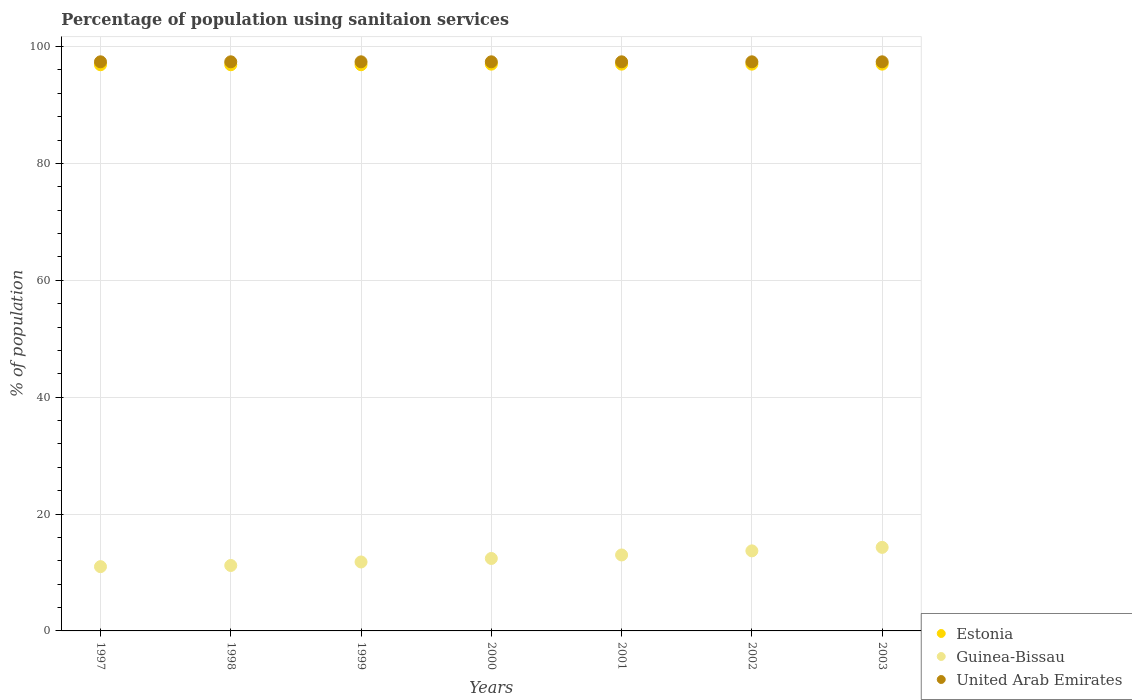How many different coloured dotlines are there?
Provide a short and direct response. 3. What is the percentage of population using sanitaion services in Estonia in 1999?
Offer a very short reply. 96.9. Across all years, what is the maximum percentage of population using sanitaion services in Estonia?
Your response must be concise. 97. Across all years, what is the minimum percentage of population using sanitaion services in Estonia?
Offer a very short reply. 96.9. In which year was the percentage of population using sanitaion services in Estonia maximum?
Provide a succinct answer. 2000. What is the total percentage of population using sanitaion services in Guinea-Bissau in the graph?
Your response must be concise. 87.4. What is the difference between the percentage of population using sanitaion services in Guinea-Bissau in 1999 and that in 2001?
Give a very brief answer. -1.2. What is the difference between the percentage of population using sanitaion services in United Arab Emirates in 1999 and the percentage of population using sanitaion services in Estonia in 2000?
Your response must be concise. 0.4. What is the average percentage of population using sanitaion services in Estonia per year?
Your answer should be compact. 96.96. In the year 2000, what is the difference between the percentage of population using sanitaion services in Estonia and percentage of population using sanitaion services in United Arab Emirates?
Offer a terse response. -0.4. In how many years, is the percentage of population using sanitaion services in Estonia greater than 56 %?
Your answer should be compact. 7. What is the ratio of the percentage of population using sanitaion services in Guinea-Bissau in 2000 to that in 2001?
Your answer should be very brief. 0.95. What is the difference between the highest and the second highest percentage of population using sanitaion services in Estonia?
Make the answer very short. 0. What is the difference between the highest and the lowest percentage of population using sanitaion services in Guinea-Bissau?
Provide a short and direct response. 3.3. Is it the case that in every year, the sum of the percentage of population using sanitaion services in United Arab Emirates and percentage of population using sanitaion services in Guinea-Bissau  is greater than the percentage of population using sanitaion services in Estonia?
Ensure brevity in your answer.  Yes. Is the percentage of population using sanitaion services in United Arab Emirates strictly less than the percentage of population using sanitaion services in Estonia over the years?
Your answer should be very brief. No. How many dotlines are there?
Give a very brief answer. 3. How many years are there in the graph?
Provide a succinct answer. 7. Does the graph contain any zero values?
Provide a succinct answer. No. Where does the legend appear in the graph?
Provide a succinct answer. Bottom right. How are the legend labels stacked?
Your answer should be very brief. Vertical. What is the title of the graph?
Keep it short and to the point. Percentage of population using sanitaion services. What is the label or title of the Y-axis?
Provide a short and direct response. % of population. What is the % of population of Estonia in 1997?
Ensure brevity in your answer.  96.9. What is the % of population in Guinea-Bissau in 1997?
Offer a terse response. 11. What is the % of population in United Arab Emirates in 1997?
Provide a short and direct response. 97.4. What is the % of population of Estonia in 1998?
Your response must be concise. 96.9. What is the % of population in Guinea-Bissau in 1998?
Ensure brevity in your answer.  11.2. What is the % of population in United Arab Emirates in 1998?
Give a very brief answer. 97.4. What is the % of population of Estonia in 1999?
Your answer should be very brief. 96.9. What is the % of population in Guinea-Bissau in 1999?
Offer a terse response. 11.8. What is the % of population of United Arab Emirates in 1999?
Ensure brevity in your answer.  97.4. What is the % of population in Estonia in 2000?
Offer a terse response. 97. What is the % of population in Guinea-Bissau in 2000?
Provide a short and direct response. 12.4. What is the % of population of United Arab Emirates in 2000?
Keep it short and to the point. 97.4. What is the % of population in Estonia in 2001?
Offer a terse response. 97. What is the % of population of United Arab Emirates in 2001?
Keep it short and to the point. 97.4. What is the % of population in Estonia in 2002?
Your answer should be very brief. 97. What is the % of population in Guinea-Bissau in 2002?
Your answer should be compact. 13.7. What is the % of population of United Arab Emirates in 2002?
Provide a short and direct response. 97.4. What is the % of population in Estonia in 2003?
Provide a short and direct response. 97. What is the % of population in United Arab Emirates in 2003?
Offer a very short reply. 97.4. Across all years, what is the maximum % of population of Estonia?
Make the answer very short. 97. Across all years, what is the maximum % of population in Guinea-Bissau?
Give a very brief answer. 14.3. Across all years, what is the maximum % of population of United Arab Emirates?
Ensure brevity in your answer.  97.4. Across all years, what is the minimum % of population of Estonia?
Make the answer very short. 96.9. Across all years, what is the minimum % of population in Guinea-Bissau?
Your response must be concise. 11. Across all years, what is the minimum % of population of United Arab Emirates?
Your answer should be compact. 97.4. What is the total % of population in Estonia in the graph?
Your answer should be very brief. 678.7. What is the total % of population in Guinea-Bissau in the graph?
Your answer should be compact. 87.4. What is the total % of population in United Arab Emirates in the graph?
Your answer should be compact. 681.8. What is the difference between the % of population of Estonia in 1997 and that in 1998?
Provide a short and direct response. 0. What is the difference between the % of population in Guinea-Bissau in 1997 and that in 1998?
Your answer should be compact. -0.2. What is the difference between the % of population in United Arab Emirates in 1997 and that in 1998?
Offer a terse response. 0. What is the difference between the % of population of Estonia in 1997 and that in 1999?
Provide a short and direct response. 0. What is the difference between the % of population of Guinea-Bissau in 1997 and that in 1999?
Provide a succinct answer. -0.8. What is the difference between the % of population of United Arab Emirates in 1997 and that in 1999?
Ensure brevity in your answer.  0. What is the difference between the % of population of Guinea-Bissau in 1997 and that in 2000?
Your answer should be compact. -1.4. What is the difference between the % of population of United Arab Emirates in 1997 and that in 2000?
Offer a very short reply. 0. What is the difference between the % of population in Guinea-Bissau in 1997 and that in 2001?
Your answer should be compact. -2. What is the difference between the % of population of United Arab Emirates in 1997 and that in 2001?
Keep it short and to the point. 0. What is the difference between the % of population of Estonia in 1997 and that in 2003?
Offer a very short reply. -0.1. What is the difference between the % of population in Guinea-Bissau in 1997 and that in 2003?
Offer a terse response. -3.3. What is the difference between the % of population in Estonia in 1998 and that in 1999?
Offer a terse response. 0. What is the difference between the % of population in Guinea-Bissau in 1998 and that in 1999?
Your answer should be compact. -0.6. What is the difference between the % of population of United Arab Emirates in 1998 and that in 2000?
Your answer should be compact. 0. What is the difference between the % of population of Estonia in 1998 and that in 2001?
Make the answer very short. -0.1. What is the difference between the % of population in Guinea-Bissau in 1998 and that in 2001?
Offer a very short reply. -1.8. What is the difference between the % of population of Estonia in 1998 and that in 2002?
Provide a succinct answer. -0.1. What is the difference between the % of population in Estonia in 1999 and that in 2000?
Offer a terse response. -0.1. What is the difference between the % of population of Guinea-Bissau in 1999 and that in 2000?
Ensure brevity in your answer.  -0.6. What is the difference between the % of population in United Arab Emirates in 1999 and that in 2000?
Your response must be concise. 0. What is the difference between the % of population of Guinea-Bissau in 1999 and that in 2001?
Your response must be concise. -1.2. What is the difference between the % of population of United Arab Emirates in 1999 and that in 2001?
Provide a succinct answer. 0. What is the difference between the % of population in Estonia in 1999 and that in 2002?
Offer a very short reply. -0.1. What is the difference between the % of population of Guinea-Bissau in 1999 and that in 2002?
Offer a very short reply. -1.9. What is the difference between the % of population in United Arab Emirates in 1999 and that in 2002?
Ensure brevity in your answer.  0. What is the difference between the % of population in Guinea-Bissau in 1999 and that in 2003?
Provide a short and direct response. -2.5. What is the difference between the % of population in United Arab Emirates in 1999 and that in 2003?
Offer a terse response. 0. What is the difference between the % of population of Estonia in 2000 and that in 2001?
Offer a terse response. 0. What is the difference between the % of population of Estonia in 2000 and that in 2002?
Offer a very short reply. 0. What is the difference between the % of population of Guinea-Bissau in 2000 and that in 2002?
Your response must be concise. -1.3. What is the difference between the % of population in United Arab Emirates in 2000 and that in 2002?
Keep it short and to the point. 0. What is the difference between the % of population in Estonia in 2000 and that in 2003?
Provide a short and direct response. 0. What is the difference between the % of population in Guinea-Bissau in 2000 and that in 2003?
Your answer should be very brief. -1.9. What is the difference between the % of population of Estonia in 2001 and that in 2002?
Your response must be concise. 0. What is the difference between the % of population in Estonia in 2001 and that in 2003?
Give a very brief answer. 0. What is the difference between the % of population of Guinea-Bissau in 2001 and that in 2003?
Your answer should be compact. -1.3. What is the difference between the % of population of Estonia in 2002 and that in 2003?
Your answer should be compact. 0. What is the difference between the % of population of Estonia in 1997 and the % of population of Guinea-Bissau in 1998?
Give a very brief answer. 85.7. What is the difference between the % of population in Estonia in 1997 and the % of population in United Arab Emirates in 1998?
Ensure brevity in your answer.  -0.5. What is the difference between the % of population of Guinea-Bissau in 1997 and the % of population of United Arab Emirates in 1998?
Your answer should be very brief. -86.4. What is the difference between the % of population of Estonia in 1997 and the % of population of Guinea-Bissau in 1999?
Your answer should be very brief. 85.1. What is the difference between the % of population of Guinea-Bissau in 1997 and the % of population of United Arab Emirates in 1999?
Keep it short and to the point. -86.4. What is the difference between the % of population in Estonia in 1997 and the % of population in Guinea-Bissau in 2000?
Make the answer very short. 84.5. What is the difference between the % of population of Guinea-Bissau in 1997 and the % of population of United Arab Emirates in 2000?
Offer a terse response. -86.4. What is the difference between the % of population in Estonia in 1997 and the % of population in Guinea-Bissau in 2001?
Your answer should be compact. 83.9. What is the difference between the % of population in Guinea-Bissau in 1997 and the % of population in United Arab Emirates in 2001?
Offer a very short reply. -86.4. What is the difference between the % of population of Estonia in 1997 and the % of population of Guinea-Bissau in 2002?
Your answer should be compact. 83.2. What is the difference between the % of population in Guinea-Bissau in 1997 and the % of population in United Arab Emirates in 2002?
Provide a short and direct response. -86.4. What is the difference between the % of population in Estonia in 1997 and the % of population in Guinea-Bissau in 2003?
Offer a terse response. 82.6. What is the difference between the % of population of Guinea-Bissau in 1997 and the % of population of United Arab Emirates in 2003?
Your answer should be very brief. -86.4. What is the difference between the % of population of Estonia in 1998 and the % of population of Guinea-Bissau in 1999?
Offer a very short reply. 85.1. What is the difference between the % of population of Guinea-Bissau in 1998 and the % of population of United Arab Emirates in 1999?
Offer a terse response. -86.2. What is the difference between the % of population of Estonia in 1998 and the % of population of Guinea-Bissau in 2000?
Provide a succinct answer. 84.5. What is the difference between the % of population in Estonia in 1998 and the % of population in United Arab Emirates in 2000?
Provide a succinct answer. -0.5. What is the difference between the % of population of Guinea-Bissau in 1998 and the % of population of United Arab Emirates in 2000?
Ensure brevity in your answer.  -86.2. What is the difference between the % of population of Estonia in 1998 and the % of population of Guinea-Bissau in 2001?
Your response must be concise. 83.9. What is the difference between the % of population of Guinea-Bissau in 1998 and the % of population of United Arab Emirates in 2001?
Your answer should be compact. -86.2. What is the difference between the % of population of Estonia in 1998 and the % of population of Guinea-Bissau in 2002?
Ensure brevity in your answer.  83.2. What is the difference between the % of population in Guinea-Bissau in 1998 and the % of population in United Arab Emirates in 2002?
Make the answer very short. -86.2. What is the difference between the % of population in Estonia in 1998 and the % of population in Guinea-Bissau in 2003?
Ensure brevity in your answer.  82.6. What is the difference between the % of population in Guinea-Bissau in 1998 and the % of population in United Arab Emirates in 2003?
Provide a succinct answer. -86.2. What is the difference between the % of population of Estonia in 1999 and the % of population of Guinea-Bissau in 2000?
Your answer should be compact. 84.5. What is the difference between the % of population of Estonia in 1999 and the % of population of United Arab Emirates in 2000?
Ensure brevity in your answer.  -0.5. What is the difference between the % of population of Guinea-Bissau in 1999 and the % of population of United Arab Emirates in 2000?
Give a very brief answer. -85.6. What is the difference between the % of population of Estonia in 1999 and the % of population of Guinea-Bissau in 2001?
Provide a succinct answer. 83.9. What is the difference between the % of population in Guinea-Bissau in 1999 and the % of population in United Arab Emirates in 2001?
Offer a very short reply. -85.6. What is the difference between the % of population in Estonia in 1999 and the % of population in Guinea-Bissau in 2002?
Provide a short and direct response. 83.2. What is the difference between the % of population of Guinea-Bissau in 1999 and the % of population of United Arab Emirates in 2002?
Your response must be concise. -85.6. What is the difference between the % of population of Estonia in 1999 and the % of population of Guinea-Bissau in 2003?
Offer a terse response. 82.6. What is the difference between the % of population in Estonia in 1999 and the % of population in United Arab Emirates in 2003?
Provide a short and direct response. -0.5. What is the difference between the % of population of Guinea-Bissau in 1999 and the % of population of United Arab Emirates in 2003?
Offer a very short reply. -85.6. What is the difference between the % of population in Guinea-Bissau in 2000 and the % of population in United Arab Emirates in 2001?
Keep it short and to the point. -85. What is the difference between the % of population in Estonia in 2000 and the % of population in Guinea-Bissau in 2002?
Your answer should be very brief. 83.3. What is the difference between the % of population of Guinea-Bissau in 2000 and the % of population of United Arab Emirates in 2002?
Offer a terse response. -85. What is the difference between the % of population in Estonia in 2000 and the % of population in Guinea-Bissau in 2003?
Ensure brevity in your answer.  82.7. What is the difference between the % of population in Guinea-Bissau in 2000 and the % of population in United Arab Emirates in 2003?
Your answer should be very brief. -85. What is the difference between the % of population of Estonia in 2001 and the % of population of Guinea-Bissau in 2002?
Your answer should be very brief. 83.3. What is the difference between the % of population of Estonia in 2001 and the % of population of United Arab Emirates in 2002?
Make the answer very short. -0.4. What is the difference between the % of population of Guinea-Bissau in 2001 and the % of population of United Arab Emirates in 2002?
Your answer should be very brief. -84.4. What is the difference between the % of population of Estonia in 2001 and the % of population of Guinea-Bissau in 2003?
Keep it short and to the point. 82.7. What is the difference between the % of population in Estonia in 2001 and the % of population in United Arab Emirates in 2003?
Give a very brief answer. -0.4. What is the difference between the % of population in Guinea-Bissau in 2001 and the % of population in United Arab Emirates in 2003?
Ensure brevity in your answer.  -84.4. What is the difference between the % of population of Estonia in 2002 and the % of population of Guinea-Bissau in 2003?
Make the answer very short. 82.7. What is the difference between the % of population of Guinea-Bissau in 2002 and the % of population of United Arab Emirates in 2003?
Your response must be concise. -83.7. What is the average % of population of Estonia per year?
Make the answer very short. 96.96. What is the average % of population of Guinea-Bissau per year?
Provide a succinct answer. 12.49. What is the average % of population in United Arab Emirates per year?
Provide a succinct answer. 97.4. In the year 1997, what is the difference between the % of population of Estonia and % of population of Guinea-Bissau?
Provide a short and direct response. 85.9. In the year 1997, what is the difference between the % of population in Guinea-Bissau and % of population in United Arab Emirates?
Keep it short and to the point. -86.4. In the year 1998, what is the difference between the % of population of Estonia and % of population of Guinea-Bissau?
Your answer should be compact. 85.7. In the year 1998, what is the difference between the % of population of Guinea-Bissau and % of population of United Arab Emirates?
Keep it short and to the point. -86.2. In the year 1999, what is the difference between the % of population in Estonia and % of population in Guinea-Bissau?
Offer a terse response. 85.1. In the year 1999, what is the difference between the % of population of Estonia and % of population of United Arab Emirates?
Give a very brief answer. -0.5. In the year 1999, what is the difference between the % of population in Guinea-Bissau and % of population in United Arab Emirates?
Provide a short and direct response. -85.6. In the year 2000, what is the difference between the % of population in Estonia and % of population in Guinea-Bissau?
Keep it short and to the point. 84.6. In the year 2000, what is the difference between the % of population of Guinea-Bissau and % of population of United Arab Emirates?
Offer a very short reply. -85. In the year 2001, what is the difference between the % of population in Estonia and % of population in Guinea-Bissau?
Your answer should be very brief. 84. In the year 2001, what is the difference between the % of population of Estonia and % of population of United Arab Emirates?
Give a very brief answer. -0.4. In the year 2001, what is the difference between the % of population of Guinea-Bissau and % of population of United Arab Emirates?
Your response must be concise. -84.4. In the year 2002, what is the difference between the % of population of Estonia and % of population of Guinea-Bissau?
Offer a very short reply. 83.3. In the year 2002, what is the difference between the % of population of Guinea-Bissau and % of population of United Arab Emirates?
Offer a very short reply. -83.7. In the year 2003, what is the difference between the % of population in Estonia and % of population in Guinea-Bissau?
Your answer should be compact. 82.7. In the year 2003, what is the difference between the % of population of Guinea-Bissau and % of population of United Arab Emirates?
Keep it short and to the point. -83.1. What is the ratio of the % of population of Guinea-Bissau in 1997 to that in 1998?
Provide a succinct answer. 0.98. What is the ratio of the % of population in United Arab Emirates in 1997 to that in 1998?
Provide a succinct answer. 1. What is the ratio of the % of population of Guinea-Bissau in 1997 to that in 1999?
Give a very brief answer. 0.93. What is the ratio of the % of population in United Arab Emirates in 1997 to that in 1999?
Your response must be concise. 1. What is the ratio of the % of population of Guinea-Bissau in 1997 to that in 2000?
Ensure brevity in your answer.  0.89. What is the ratio of the % of population in Guinea-Bissau in 1997 to that in 2001?
Provide a succinct answer. 0.85. What is the ratio of the % of population of Estonia in 1997 to that in 2002?
Offer a very short reply. 1. What is the ratio of the % of population of Guinea-Bissau in 1997 to that in 2002?
Give a very brief answer. 0.8. What is the ratio of the % of population in Estonia in 1997 to that in 2003?
Ensure brevity in your answer.  1. What is the ratio of the % of population in Guinea-Bissau in 1997 to that in 2003?
Make the answer very short. 0.77. What is the ratio of the % of population of United Arab Emirates in 1997 to that in 2003?
Offer a terse response. 1. What is the ratio of the % of population in Estonia in 1998 to that in 1999?
Your answer should be compact. 1. What is the ratio of the % of population in Guinea-Bissau in 1998 to that in 1999?
Make the answer very short. 0.95. What is the ratio of the % of population in Estonia in 1998 to that in 2000?
Give a very brief answer. 1. What is the ratio of the % of population of Guinea-Bissau in 1998 to that in 2000?
Your answer should be compact. 0.9. What is the ratio of the % of population in Estonia in 1998 to that in 2001?
Keep it short and to the point. 1. What is the ratio of the % of population of Guinea-Bissau in 1998 to that in 2001?
Provide a short and direct response. 0.86. What is the ratio of the % of population in United Arab Emirates in 1998 to that in 2001?
Offer a very short reply. 1. What is the ratio of the % of population of Guinea-Bissau in 1998 to that in 2002?
Offer a terse response. 0.82. What is the ratio of the % of population in Estonia in 1998 to that in 2003?
Provide a succinct answer. 1. What is the ratio of the % of population of Guinea-Bissau in 1998 to that in 2003?
Give a very brief answer. 0.78. What is the ratio of the % of population in Estonia in 1999 to that in 2000?
Offer a terse response. 1. What is the ratio of the % of population of Guinea-Bissau in 1999 to that in 2000?
Provide a succinct answer. 0.95. What is the ratio of the % of population of Estonia in 1999 to that in 2001?
Provide a succinct answer. 1. What is the ratio of the % of population in Guinea-Bissau in 1999 to that in 2001?
Provide a succinct answer. 0.91. What is the ratio of the % of population in United Arab Emirates in 1999 to that in 2001?
Keep it short and to the point. 1. What is the ratio of the % of population in Estonia in 1999 to that in 2002?
Keep it short and to the point. 1. What is the ratio of the % of population of Guinea-Bissau in 1999 to that in 2002?
Keep it short and to the point. 0.86. What is the ratio of the % of population of United Arab Emirates in 1999 to that in 2002?
Give a very brief answer. 1. What is the ratio of the % of population in Estonia in 1999 to that in 2003?
Make the answer very short. 1. What is the ratio of the % of population of Guinea-Bissau in 1999 to that in 2003?
Keep it short and to the point. 0.83. What is the ratio of the % of population of Guinea-Bissau in 2000 to that in 2001?
Your response must be concise. 0.95. What is the ratio of the % of population in United Arab Emirates in 2000 to that in 2001?
Keep it short and to the point. 1. What is the ratio of the % of population in Estonia in 2000 to that in 2002?
Your response must be concise. 1. What is the ratio of the % of population of Guinea-Bissau in 2000 to that in 2002?
Your response must be concise. 0.91. What is the ratio of the % of population in United Arab Emirates in 2000 to that in 2002?
Give a very brief answer. 1. What is the ratio of the % of population of Estonia in 2000 to that in 2003?
Ensure brevity in your answer.  1. What is the ratio of the % of population of Guinea-Bissau in 2000 to that in 2003?
Offer a terse response. 0.87. What is the ratio of the % of population of United Arab Emirates in 2000 to that in 2003?
Your answer should be compact. 1. What is the ratio of the % of population in Guinea-Bissau in 2001 to that in 2002?
Provide a succinct answer. 0.95. What is the ratio of the % of population in United Arab Emirates in 2001 to that in 2002?
Offer a terse response. 1. What is the ratio of the % of population in Guinea-Bissau in 2001 to that in 2003?
Offer a terse response. 0.91. What is the ratio of the % of population of Guinea-Bissau in 2002 to that in 2003?
Your answer should be compact. 0.96. What is the difference between the highest and the second highest % of population in Estonia?
Your response must be concise. 0. What is the difference between the highest and the second highest % of population in Guinea-Bissau?
Make the answer very short. 0.6. What is the difference between the highest and the second highest % of population of United Arab Emirates?
Ensure brevity in your answer.  0. What is the difference between the highest and the lowest % of population in Guinea-Bissau?
Provide a short and direct response. 3.3. 